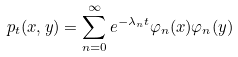<formula> <loc_0><loc_0><loc_500><loc_500>p _ { t } ( x , y ) = \sum _ { n = 0 } ^ { \infty } e ^ { - \lambda _ { n } t } \varphi _ { n } ( x ) \varphi _ { n } ( y )</formula> 